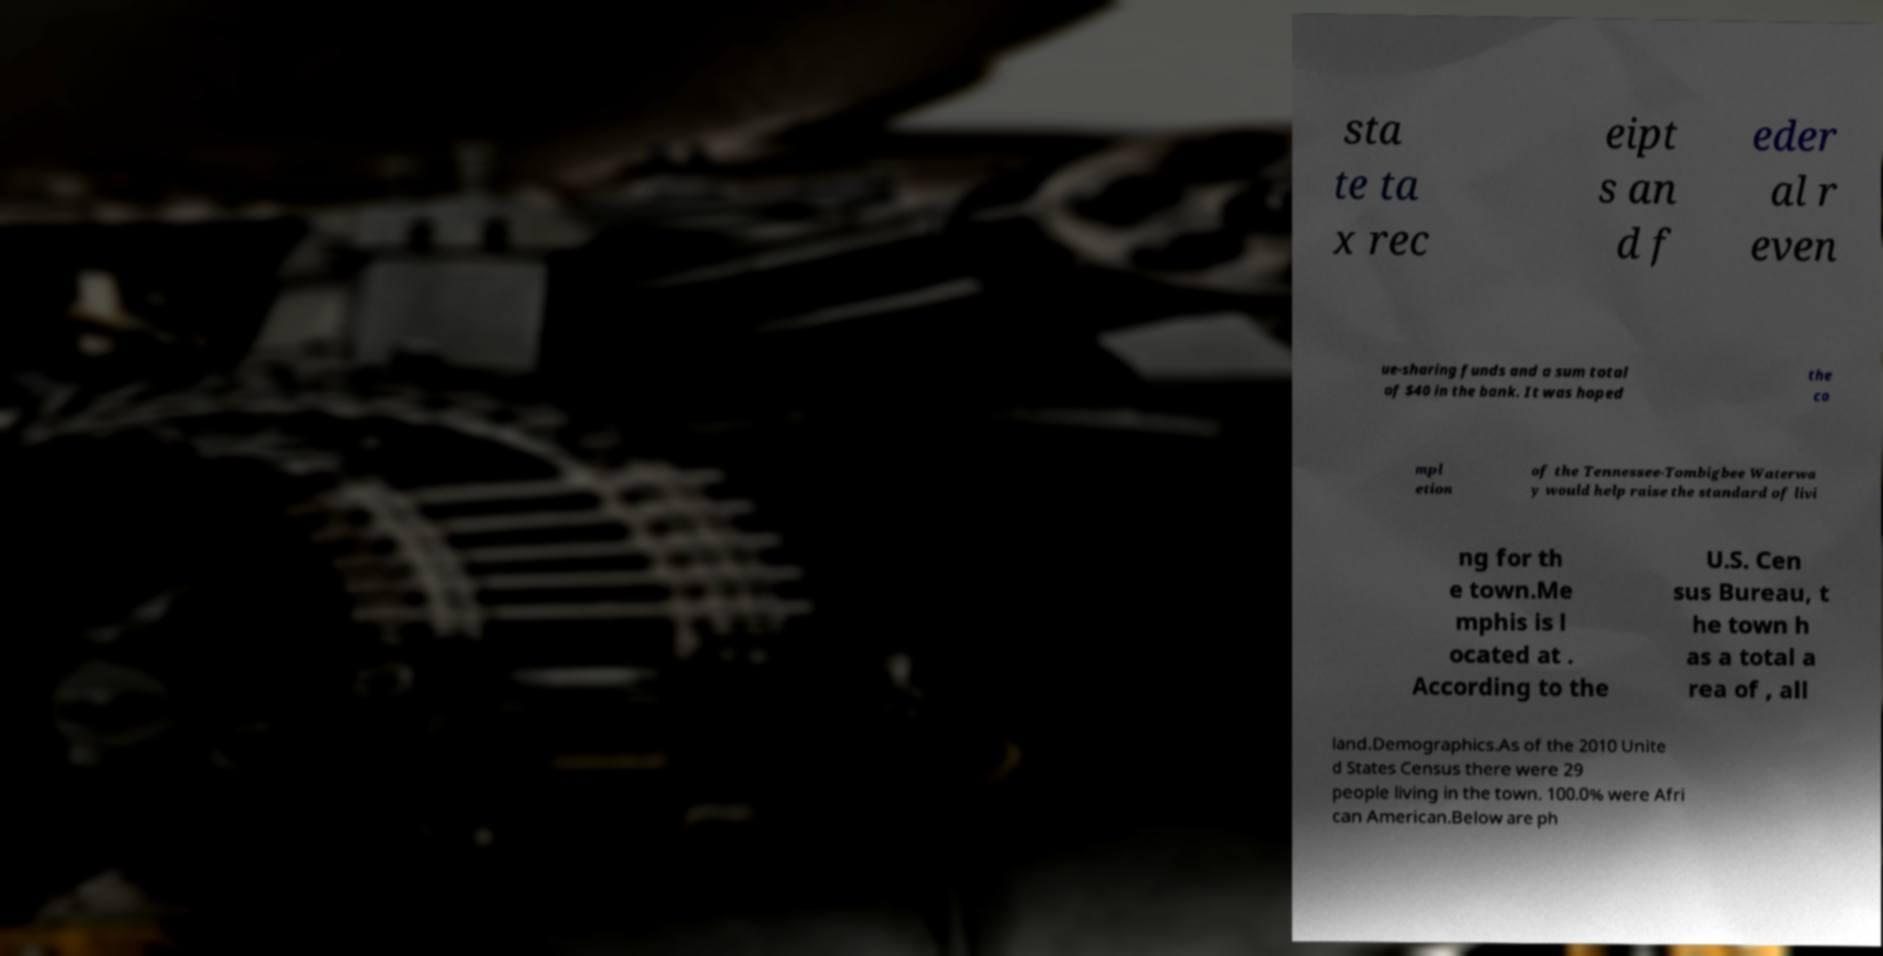Can you read and provide the text displayed in the image?This photo seems to have some interesting text. Can you extract and type it out for me? sta te ta x rec eipt s an d f eder al r even ue-sharing funds and a sum total of $40 in the bank. It was hoped the co mpl etion of the Tennessee-Tombigbee Waterwa y would help raise the standard of livi ng for th e town.Me mphis is l ocated at . According to the U.S. Cen sus Bureau, t he town h as a total a rea of , all land.Demographics.As of the 2010 Unite d States Census there were 29 people living in the town. 100.0% were Afri can American.Below are ph 